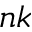<formula> <loc_0><loc_0><loc_500><loc_500>n k</formula> 